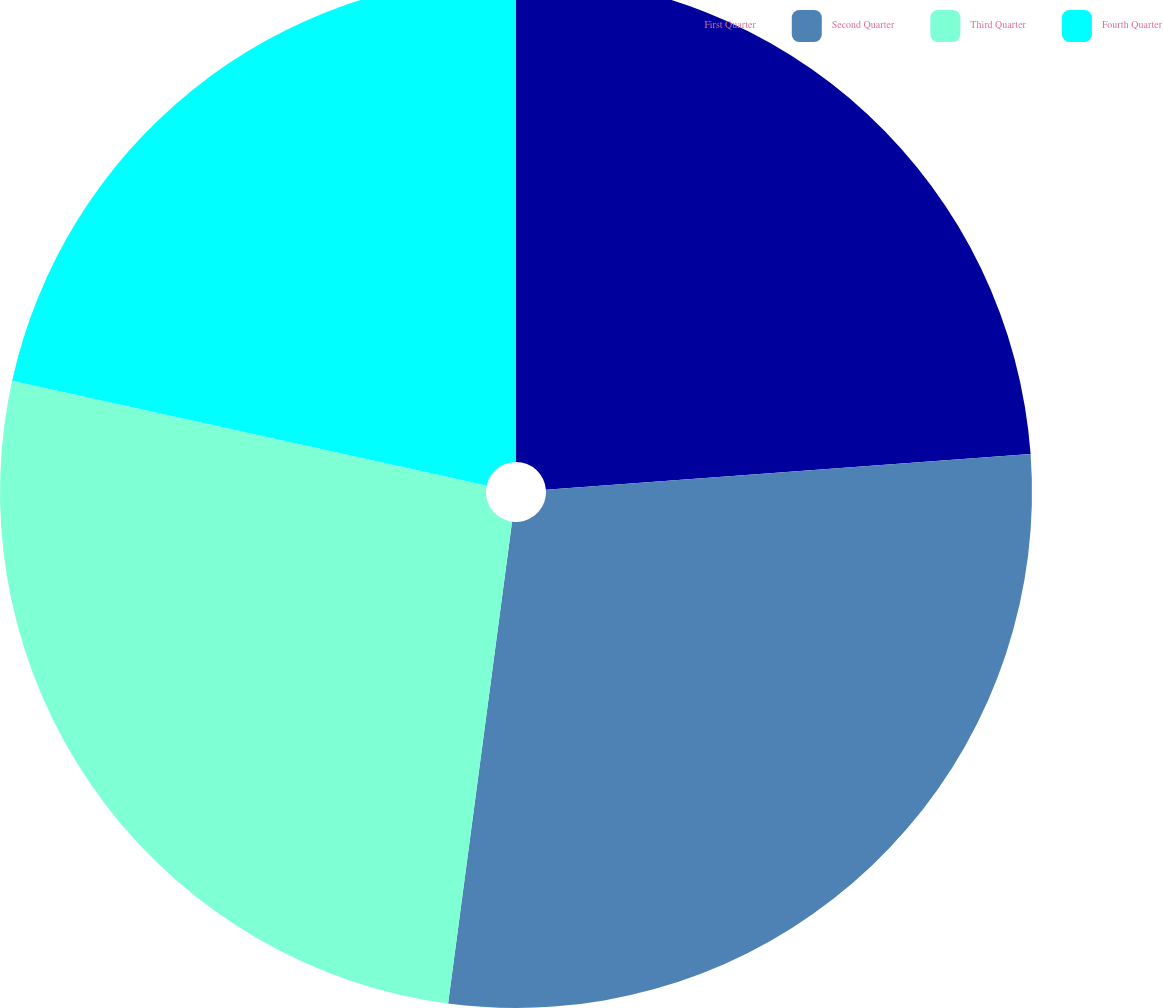<chart> <loc_0><loc_0><loc_500><loc_500><pie_chart><fcel>First Quarter<fcel>Second Quarter<fcel>Third Quarter<fcel>Fourth Quarter<nl><fcel>23.83%<fcel>28.27%<fcel>26.36%<fcel>21.54%<nl></chart> 